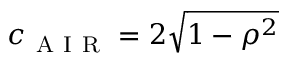<formula> <loc_0><loc_0><loc_500><loc_500>c _ { A I R } = 2 \sqrt { 1 - \rho ^ { 2 } }</formula> 